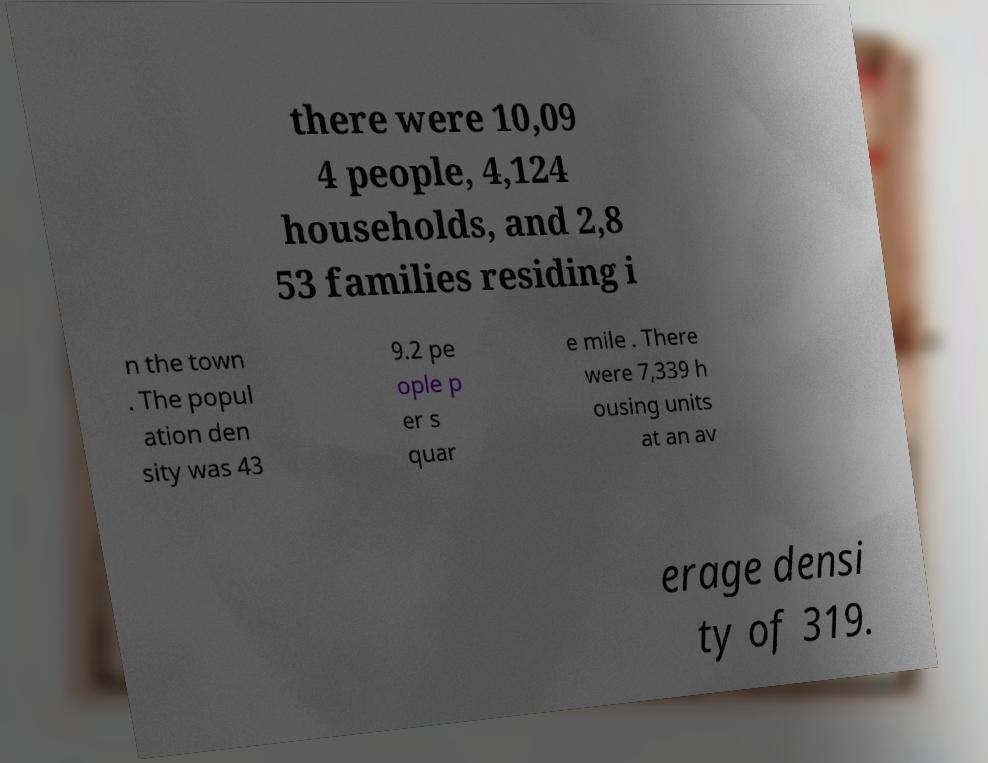Can you read and provide the text displayed in the image?This photo seems to have some interesting text. Can you extract and type it out for me? there were 10,09 4 people, 4,124 households, and 2,8 53 families residing i n the town . The popul ation den sity was 43 9.2 pe ople p er s quar e mile . There were 7,339 h ousing units at an av erage densi ty of 319. 